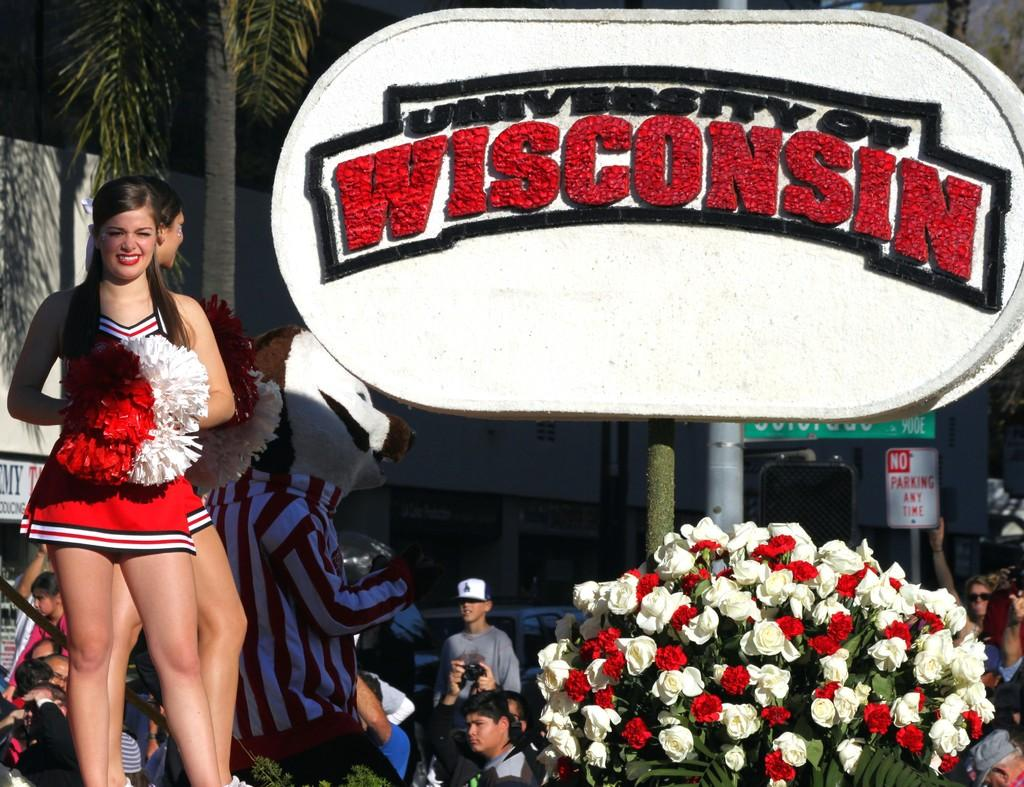<image>
Offer a succinct explanation of the picture presented. University of Wisconsin ceremony giving a speech an honor of an event that has happened. 